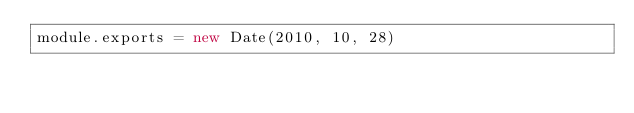<code> <loc_0><loc_0><loc_500><loc_500><_JavaScript_>module.exports = new Date(2010, 10, 28)
</code> 